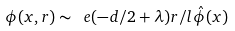Convert formula to latex. <formula><loc_0><loc_0><loc_500><loc_500>\phi ( x , r ) \sim \ e { ( - d / 2 + \lambda ) r / l } \hat { \phi } ( x )</formula> 